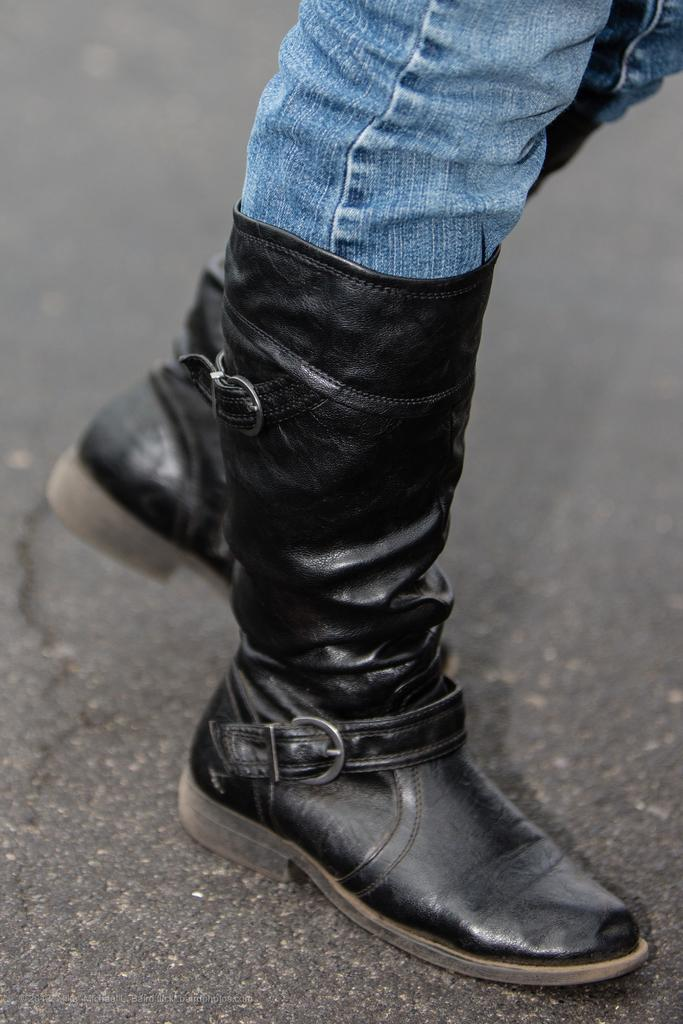What part of a person can be seen in the image? There is a person's legs visible in the image. What type of clothing is the person wearing on their legs? The person is wearing jeans. What type of footwear is the person wearing? The person is wearing black boots. Where are the legs located in the image? The legs are on the road. What type of plants can be seen growing in the person's home in the image? There is no reference to a home or plants in the image; it only shows a person's legs on the road. 